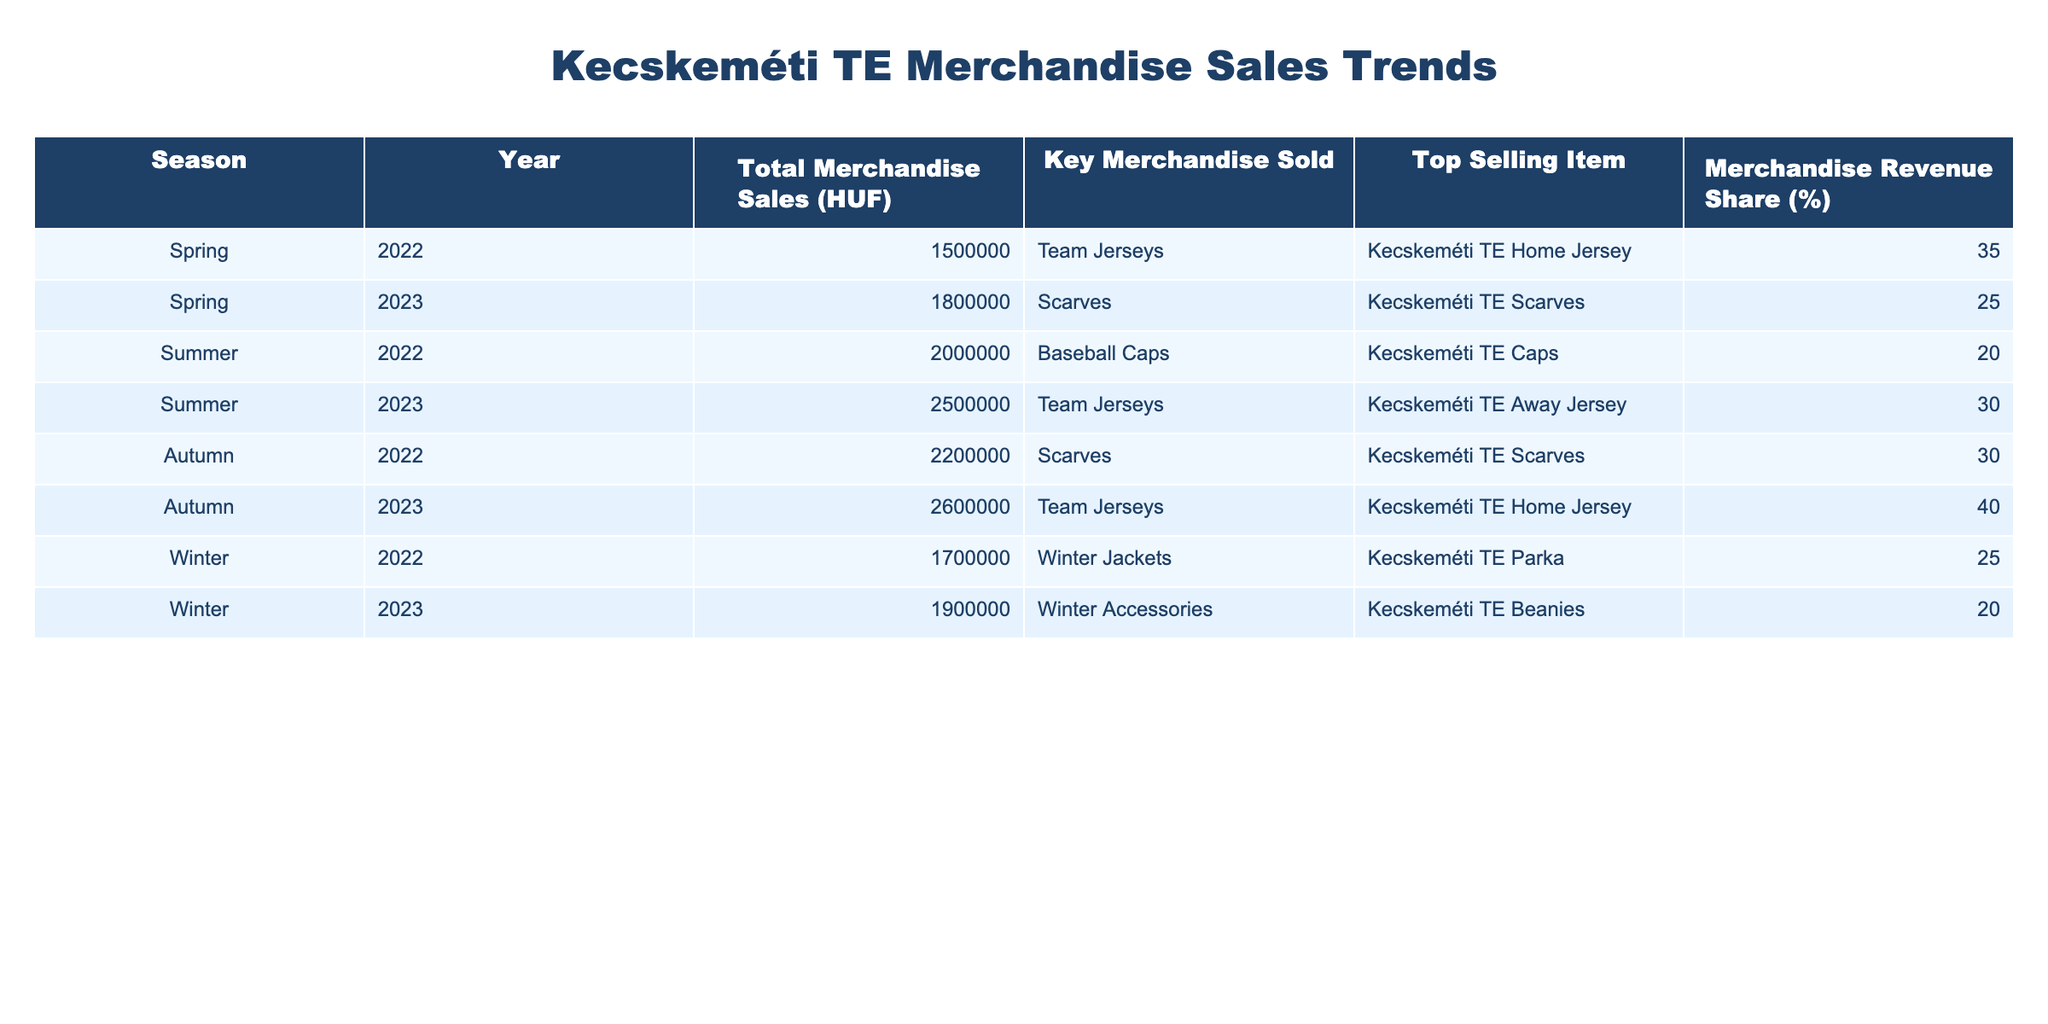What was the total merchandise sales for Kecskeméti TE in Spring 2023? The table shows the total merchandise sales in Spring 2023 as 1,800,000 HUF.
Answer: 1,800,000 HUF Which item had the highest merchandise revenue share in Autumn 2023? According to the table, the top-selling item in Autumn 2023 was the Kecskeméti TE Home Jersey with a revenue share of 40%.
Answer: Kecskeméti TE Home Jersey What is the total merchandise sales for both Summer seasons in 2022 and 2023? From the table, Summer 2022 had sales of 2,000,000 HUF and Summer 2023 had sales of 2,500,000 HUF. Adding these gives 2,000,000 + 2,500,000 = 4,500,000 HUF.
Answer: 4,500,000 HUF Did Kecskeméti TE's merchandise sales increase from Autumn 2022 to Autumn 2023? Yes, the table shows that merchandise sales increased from 2,200,000 HUF in Autumn 2022 to 2,600,000 HUF in Autumn 2023.
Answer: Yes Which season had the lowest total merchandise sales, and what was the amount? The table indicates the lowest total merchandise sales occurred in Spring 2022, with an amount of 1,500,000 HUF.
Answer: Spring 2022, 1,500,000 HUF What was the average merchandise sales across all seasons in 2022? Summing the total merchandise sales for 2022: 1,500,000 (Spring) + 2,000,000 (Summer) + 2,200,000 (Autumn) + 1,700,000 (Winter) = 7,400,000 HUF. There are 4 seasons, so the average is 7,400,000 / 4 = 1,850,000 HUF.
Answer: 1,850,000 HUF What was the key merchandise sold in Winter 2022? The key merchandise sold in Winter 2022, as per the table, was Winter Jackets, specifically the Kecskeméti TE Parka.
Answer: Winter Jackets, Kecskeméti TE Parka How much did the merchandise sales increase from Winter 2022 to Winter 2023? The sales in Winter 2022 were 1,700,000 HUF and in Winter 2023 were 1,900,000 HUF. The increase is 1,900,000 - 1,700,000 = 200,000 HUF.
Answer: 200,000 HUF Which season had the highest total merchandise revenue share for team jerseys? The table shows that Autumn 2023 had the highest merchandise revenue share for team jerseys at 40%.
Answer: Autumn 2023 What item had the highest total merchandise sales in Summer 2023? According to the table, the team jersey, specifically the Kecskeméti TE Away Jersey, was the top-selling item in Summer 2023.
Answer: Kecskeméti TE Away Jersey 